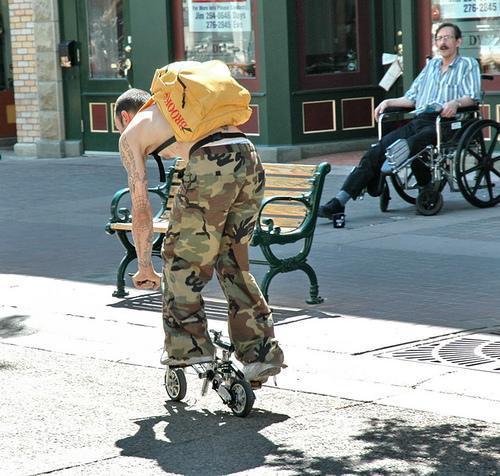How many people can you see?
Give a very brief answer. 2. 